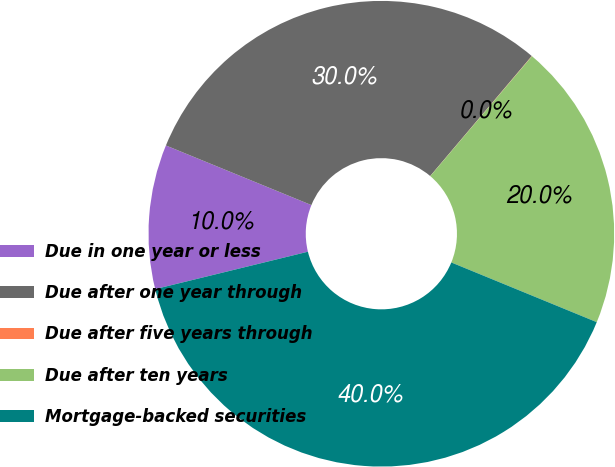Convert chart to OTSL. <chart><loc_0><loc_0><loc_500><loc_500><pie_chart><fcel>Due in one year or less<fcel>Due after one year through<fcel>Due after five years through<fcel>Due after ten years<fcel>Mortgage-backed securities<nl><fcel>10.01%<fcel>29.99%<fcel>0.02%<fcel>20.0%<fcel>39.98%<nl></chart> 